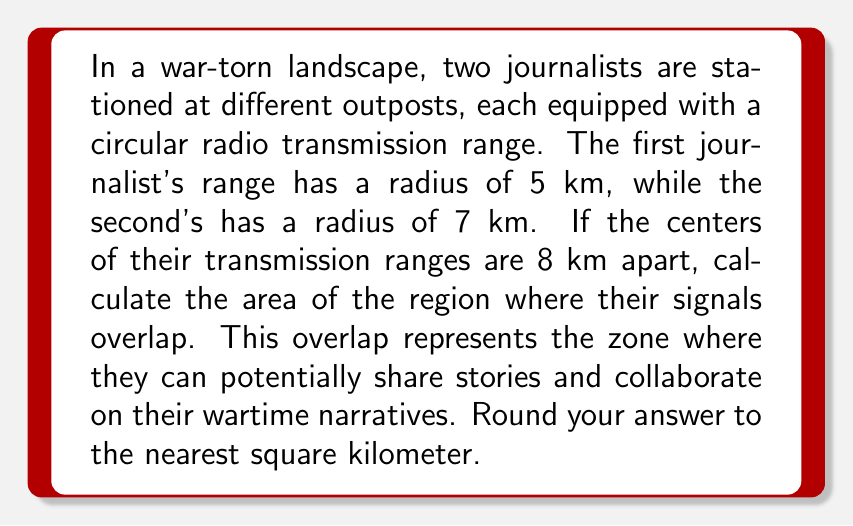Solve this math problem. Let's approach this step-by-step:

1) This problem involves finding the area of overlap between two circles. We can use the formula for the area of intersection of two circles:

   $$A = r_1^2 \arccos(\frac{d^2 + r_1^2 - r_2^2}{2dr_1}) + r_2^2 \arccos(\frac{d^2 + r_2^2 - r_1^2}{2dr_2}) - \frac{1}{2}\sqrt{(-d+r_1+r_2)(d+r_1-r_2)(d-r_1+r_2)(d+r_1+r_2)}$$

   Where $r_1$ and $r_2$ are the radii of the circles, and $d$ is the distance between their centers.

2) We have:
   $r_1 = 5$ km
   $r_2 = 7$ km
   $d = 8$ km

3) Let's substitute these values into our formula:

   $$A = 5^2 \arccos(\frac{8^2 + 5^2 - 7^2}{2 \cdot 8 \cdot 5}) + 7^2 \arccos(\frac{8^2 + 7^2 - 5^2}{2 \cdot 8 \cdot 7}) - \frac{1}{2}\sqrt{(-8+5+7)(8+5-7)(8-5+7)(8+5+7)}$$

4) Simplifying inside the arccos functions:

   $$A = 25 \arccos(\frac{64 + 25 - 49}{80}) + 49 \arccos(\frac{64 + 49 - 25}{112}) - \frac{1}{2}\sqrt{4 \cdot 6 \cdot 10 \cdot 20}$$

5) Simplifying further:

   $$A = 25 \arccos(0.5) + 49 \arccos(0.7857) - \frac{1}{2}\sqrt{4800}$$

6) Calculating:

   $$A \approx 25 \cdot 1.0472 + 49 \cdot 0.6435 - 34.6410$$
   $$A \approx 26.18 + 31.5315 - 34.6410$$
   $$A \approx 23.0705$$

7) Rounding to the nearest square kilometer:

   $$A \approx 23 \text{ km}^2$$

[asy]
import geometry;

pair O1 = (0,0);
pair O2 = (8,0);
real r1 = 5;
real r2 = 7;

draw(circle(O1,r1));
draw(circle(O2,r2));
draw(O1--O2,dashed);

label("5 km",O1,NW);
label("7 km",O2,NE);
label("8 km",(4,0),S);

fill(buildcycle(arc(O1,r1,angles(O2-O1)[0],angles(O2-O1)[1]),
                arc(O2,r2,angles(O1-O2)[0],angles(O1-O2)[1])),
     gray(0.7));
[/asy]
Answer: 23 km² 